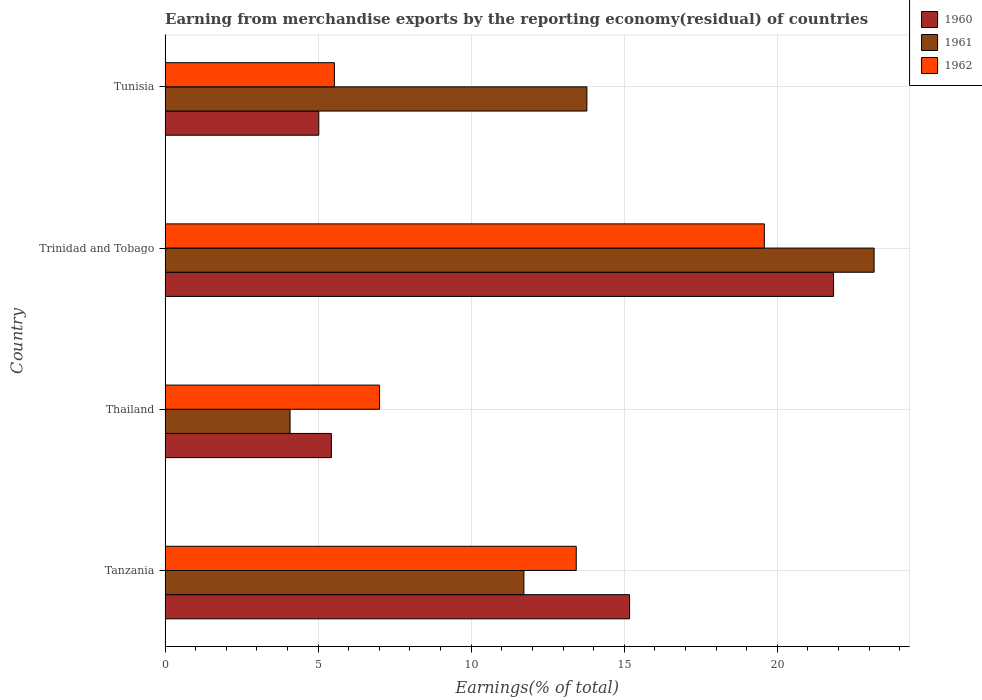How many groups of bars are there?
Your response must be concise. 4. Are the number of bars on each tick of the Y-axis equal?
Offer a terse response. Yes. How many bars are there on the 1st tick from the bottom?
Offer a very short reply. 3. What is the label of the 1st group of bars from the top?
Ensure brevity in your answer.  Tunisia. What is the percentage of amount earned from merchandise exports in 1960 in Tunisia?
Provide a succinct answer. 5.02. Across all countries, what is the maximum percentage of amount earned from merchandise exports in 1962?
Ensure brevity in your answer.  19.58. Across all countries, what is the minimum percentage of amount earned from merchandise exports in 1961?
Your answer should be compact. 4.08. In which country was the percentage of amount earned from merchandise exports in 1961 maximum?
Ensure brevity in your answer.  Trinidad and Tobago. In which country was the percentage of amount earned from merchandise exports in 1962 minimum?
Keep it short and to the point. Tunisia. What is the total percentage of amount earned from merchandise exports in 1962 in the graph?
Offer a terse response. 45.55. What is the difference between the percentage of amount earned from merchandise exports in 1961 in Thailand and that in Trinidad and Tobago?
Your response must be concise. -19.08. What is the difference between the percentage of amount earned from merchandise exports in 1962 in Tunisia and the percentage of amount earned from merchandise exports in 1960 in Trinidad and Tobago?
Your answer should be compact. -16.31. What is the average percentage of amount earned from merchandise exports in 1961 per country?
Make the answer very short. 13.19. What is the difference between the percentage of amount earned from merchandise exports in 1962 and percentage of amount earned from merchandise exports in 1960 in Thailand?
Ensure brevity in your answer.  1.57. What is the ratio of the percentage of amount earned from merchandise exports in 1962 in Tanzania to that in Trinidad and Tobago?
Provide a short and direct response. 0.69. What is the difference between the highest and the second highest percentage of amount earned from merchandise exports in 1960?
Your response must be concise. 6.66. What is the difference between the highest and the lowest percentage of amount earned from merchandise exports in 1960?
Ensure brevity in your answer.  16.82. Is the sum of the percentage of amount earned from merchandise exports in 1960 in Tanzania and Trinidad and Tobago greater than the maximum percentage of amount earned from merchandise exports in 1962 across all countries?
Make the answer very short. Yes. What does the 1st bar from the top in Tunisia represents?
Offer a very short reply. 1962. Is it the case that in every country, the sum of the percentage of amount earned from merchandise exports in 1960 and percentage of amount earned from merchandise exports in 1961 is greater than the percentage of amount earned from merchandise exports in 1962?
Offer a very short reply. Yes. How many countries are there in the graph?
Give a very brief answer. 4. What is the difference between two consecutive major ticks on the X-axis?
Your answer should be compact. 5. Are the values on the major ticks of X-axis written in scientific E-notation?
Ensure brevity in your answer.  No. Does the graph contain grids?
Your response must be concise. Yes. How many legend labels are there?
Offer a very short reply. 3. How are the legend labels stacked?
Your response must be concise. Vertical. What is the title of the graph?
Your answer should be very brief. Earning from merchandise exports by the reporting economy(residual) of countries. Does "2009" appear as one of the legend labels in the graph?
Offer a very short reply. No. What is the label or title of the X-axis?
Give a very brief answer. Earnings(% of total). What is the label or title of the Y-axis?
Your response must be concise. Country. What is the Earnings(% of total) of 1960 in Tanzania?
Make the answer very short. 15.18. What is the Earnings(% of total) of 1961 in Tanzania?
Provide a succinct answer. 11.72. What is the Earnings(% of total) of 1962 in Tanzania?
Keep it short and to the point. 13.43. What is the Earnings(% of total) of 1960 in Thailand?
Give a very brief answer. 5.43. What is the Earnings(% of total) in 1961 in Thailand?
Provide a short and direct response. 4.08. What is the Earnings(% of total) of 1962 in Thailand?
Your answer should be very brief. 7.01. What is the Earnings(% of total) of 1960 in Trinidad and Tobago?
Ensure brevity in your answer.  21.84. What is the Earnings(% of total) of 1961 in Trinidad and Tobago?
Ensure brevity in your answer.  23.16. What is the Earnings(% of total) of 1962 in Trinidad and Tobago?
Your answer should be very brief. 19.58. What is the Earnings(% of total) of 1960 in Tunisia?
Give a very brief answer. 5.02. What is the Earnings(% of total) in 1961 in Tunisia?
Provide a short and direct response. 13.78. What is the Earnings(% of total) in 1962 in Tunisia?
Ensure brevity in your answer.  5.53. Across all countries, what is the maximum Earnings(% of total) of 1960?
Your response must be concise. 21.84. Across all countries, what is the maximum Earnings(% of total) of 1961?
Ensure brevity in your answer.  23.16. Across all countries, what is the maximum Earnings(% of total) of 1962?
Your response must be concise. 19.58. Across all countries, what is the minimum Earnings(% of total) in 1960?
Provide a short and direct response. 5.02. Across all countries, what is the minimum Earnings(% of total) of 1961?
Give a very brief answer. 4.08. Across all countries, what is the minimum Earnings(% of total) of 1962?
Make the answer very short. 5.53. What is the total Earnings(% of total) of 1960 in the graph?
Provide a succinct answer. 47.47. What is the total Earnings(% of total) in 1961 in the graph?
Offer a very short reply. 52.75. What is the total Earnings(% of total) of 1962 in the graph?
Offer a terse response. 45.55. What is the difference between the Earnings(% of total) in 1960 in Tanzania and that in Thailand?
Offer a very short reply. 9.74. What is the difference between the Earnings(% of total) of 1961 in Tanzania and that in Thailand?
Make the answer very short. 7.64. What is the difference between the Earnings(% of total) in 1962 in Tanzania and that in Thailand?
Offer a very short reply. 6.43. What is the difference between the Earnings(% of total) in 1960 in Tanzania and that in Trinidad and Tobago?
Provide a short and direct response. -6.66. What is the difference between the Earnings(% of total) of 1961 in Tanzania and that in Trinidad and Tobago?
Make the answer very short. -11.44. What is the difference between the Earnings(% of total) in 1962 in Tanzania and that in Trinidad and Tobago?
Ensure brevity in your answer.  -6.14. What is the difference between the Earnings(% of total) in 1960 in Tanzania and that in Tunisia?
Ensure brevity in your answer.  10.15. What is the difference between the Earnings(% of total) of 1961 in Tanzania and that in Tunisia?
Keep it short and to the point. -2.06. What is the difference between the Earnings(% of total) in 1962 in Tanzania and that in Tunisia?
Your response must be concise. 7.9. What is the difference between the Earnings(% of total) in 1960 in Thailand and that in Trinidad and Tobago?
Make the answer very short. -16.41. What is the difference between the Earnings(% of total) of 1961 in Thailand and that in Trinidad and Tobago?
Offer a terse response. -19.08. What is the difference between the Earnings(% of total) of 1962 in Thailand and that in Trinidad and Tobago?
Provide a short and direct response. -12.57. What is the difference between the Earnings(% of total) of 1960 in Thailand and that in Tunisia?
Provide a short and direct response. 0.41. What is the difference between the Earnings(% of total) in 1961 in Thailand and that in Tunisia?
Make the answer very short. -9.7. What is the difference between the Earnings(% of total) in 1962 in Thailand and that in Tunisia?
Offer a very short reply. 1.48. What is the difference between the Earnings(% of total) of 1960 in Trinidad and Tobago and that in Tunisia?
Provide a succinct answer. 16.82. What is the difference between the Earnings(% of total) of 1961 in Trinidad and Tobago and that in Tunisia?
Ensure brevity in your answer.  9.38. What is the difference between the Earnings(% of total) of 1962 in Trinidad and Tobago and that in Tunisia?
Offer a very short reply. 14.05. What is the difference between the Earnings(% of total) of 1960 in Tanzania and the Earnings(% of total) of 1961 in Thailand?
Keep it short and to the point. 11.09. What is the difference between the Earnings(% of total) in 1960 in Tanzania and the Earnings(% of total) in 1962 in Thailand?
Offer a terse response. 8.17. What is the difference between the Earnings(% of total) of 1961 in Tanzania and the Earnings(% of total) of 1962 in Thailand?
Your answer should be very brief. 4.72. What is the difference between the Earnings(% of total) of 1960 in Tanzania and the Earnings(% of total) of 1961 in Trinidad and Tobago?
Make the answer very short. -7.99. What is the difference between the Earnings(% of total) in 1960 in Tanzania and the Earnings(% of total) in 1962 in Trinidad and Tobago?
Your answer should be compact. -4.4. What is the difference between the Earnings(% of total) in 1961 in Tanzania and the Earnings(% of total) in 1962 in Trinidad and Tobago?
Keep it short and to the point. -7.86. What is the difference between the Earnings(% of total) in 1960 in Tanzania and the Earnings(% of total) in 1961 in Tunisia?
Keep it short and to the point. 1.39. What is the difference between the Earnings(% of total) of 1960 in Tanzania and the Earnings(% of total) of 1962 in Tunisia?
Your response must be concise. 9.64. What is the difference between the Earnings(% of total) of 1961 in Tanzania and the Earnings(% of total) of 1962 in Tunisia?
Offer a terse response. 6.19. What is the difference between the Earnings(% of total) of 1960 in Thailand and the Earnings(% of total) of 1961 in Trinidad and Tobago?
Keep it short and to the point. -17.73. What is the difference between the Earnings(% of total) of 1960 in Thailand and the Earnings(% of total) of 1962 in Trinidad and Tobago?
Make the answer very short. -14.14. What is the difference between the Earnings(% of total) of 1961 in Thailand and the Earnings(% of total) of 1962 in Trinidad and Tobago?
Your answer should be compact. -15.49. What is the difference between the Earnings(% of total) in 1960 in Thailand and the Earnings(% of total) in 1961 in Tunisia?
Ensure brevity in your answer.  -8.35. What is the difference between the Earnings(% of total) in 1960 in Thailand and the Earnings(% of total) in 1962 in Tunisia?
Your answer should be very brief. -0.1. What is the difference between the Earnings(% of total) in 1961 in Thailand and the Earnings(% of total) in 1962 in Tunisia?
Give a very brief answer. -1.45. What is the difference between the Earnings(% of total) in 1960 in Trinidad and Tobago and the Earnings(% of total) in 1961 in Tunisia?
Provide a short and direct response. 8.06. What is the difference between the Earnings(% of total) of 1960 in Trinidad and Tobago and the Earnings(% of total) of 1962 in Tunisia?
Your response must be concise. 16.31. What is the difference between the Earnings(% of total) in 1961 in Trinidad and Tobago and the Earnings(% of total) in 1962 in Tunisia?
Your answer should be very brief. 17.63. What is the average Earnings(% of total) in 1960 per country?
Keep it short and to the point. 11.87. What is the average Earnings(% of total) in 1961 per country?
Your response must be concise. 13.19. What is the average Earnings(% of total) in 1962 per country?
Provide a short and direct response. 11.39. What is the difference between the Earnings(% of total) of 1960 and Earnings(% of total) of 1961 in Tanzania?
Provide a short and direct response. 3.45. What is the difference between the Earnings(% of total) in 1960 and Earnings(% of total) in 1962 in Tanzania?
Keep it short and to the point. 1.74. What is the difference between the Earnings(% of total) of 1961 and Earnings(% of total) of 1962 in Tanzania?
Keep it short and to the point. -1.71. What is the difference between the Earnings(% of total) in 1960 and Earnings(% of total) in 1961 in Thailand?
Keep it short and to the point. 1.35. What is the difference between the Earnings(% of total) of 1960 and Earnings(% of total) of 1962 in Thailand?
Make the answer very short. -1.57. What is the difference between the Earnings(% of total) of 1961 and Earnings(% of total) of 1962 in Thailand?
Offer a terse response. -2.92. What is the difference between the Earnings(% of total) in 1960 and Earnings(% of total) in 1961 in Trinidad and Tobago?
Make the answer very short. -1.32. What is the difference between the Earnings(% of total) of 1960 and Earnings(% of total) of 1962 in Trinidad and Tobago?
Give a very brief answer. 2.26. What is the difference between the Earnings(% of total) of 1961 and Earnings(% of total) of 1962 in Trinidad and Tobago?
Your response must be concise. 3.59. What is the difference between the Earnings(% of total) of 1960 and Earnings(% of total) of 1961 in Tunisia?
Your response must be concise. -8.76. What is the difference between the Earnings(% of total) of 1960 and Earnings(% of total) of 1962 in Tunisia?
Give a very brief answer. -0.51. What is the difference between the Earnings(% of total) in 1961 and Earnings(% of total) in 1962 in Tunisia?
Provide a short and direct response. 8.25. What is the ratio of the Earnings(% of total) of 1960 in Tanzania to that in Thailand?
Keep it short and to the point. 2.79. What is the ratio of the Earnings(% of total) in 1961 in Tanzania to that in Thailand?
Your answer should be very brief. 2.87. What is the ratio of the Earnings(% of total) of 1962 in Tanzania to that in Thailand?
Offer a very short reply. 1.92. What is the ratio of the Earnings(% of total) in 1960 in Tanzania to that in Trinidad and Tobago?
Make the answer very short. 0.69. What is the ratio of the Earnings(% of total) of 1961 in Tanzania to that in Trinidad and Tobago?
Your response must be concise. 0.51. What is the ratio of the Earnings(% of total) in 1962 in Tanzania to that in Trinidad and Tobago?
Offer a terse response. 0.69. What is the ratio of the Earnings(% of total) in 1960 in Tanzania to that in Tunisia?
Your answer should be very brief. 3.02. What is the ratio of the Earnings(% of total) in 1961 in Tanzania to that in Tunisia?
Make the answer very short. 0.85. What is the ratio of the Earnings(% of total) of 1962 in Tanzania to that in Tunisia?
Offer a very short reply. 2.43. What is the ratio of the Earnings(% of total) in 1960 in Thailand to that in Trinidad and Tobago?
Keep it short and to the point. 0.25. What is the ratio of the Earnings(% of total) in 1961 in Thailand to that in Trinidad and Tobago?
Keep it short and to the point. 0.18. What is the ratio of the Earnings(% of total) in 1962 in Thailand to that in Trinidad and Tobago?
Provide a succinct answer. 0.36. What is the ratio of the Earnings(% of total) of 1960 in Thailand to that in Tunisia?
Make the answer very short. 1.08. What is the ratio of the Earnings(% of total) in 1961 in Thailand to that in Tunisia?
Offer a very short reply. 0.3. What is the ratio of the Earnings(% of total) of 1962 in Thailand to that in Tunisia?
Offer a very short reply. 1.27. What is the ratio of the Earnings(% of total) of 1960 in Trinidad and Tobago to that in Tunisia?
Offer a terse response. 4.35. What is the ratio of the Earnings(% of total) of 1961 in Trinidad and Tobago to that in Tunisia?
Make the answer very short. 1.68. What is the ratio of the Earnings(% of total) of 1962 in Trinidad and Tobago to that in Tunisia?
Give a very brief answer. 3.54. What is the difference between the highest and the second highest Earnings(% of total) of 1960?
Your answer should be very brief. 6.66. What is the difference between the highest and the second highest Earnings(% of total) of 1961?
Offer a very short reply. 9.38. What is the difference between the highest and the second highest Earnings(% of total) of 1962?
Give a very brief answer. 6.14. What is the difference between the highest and the lowest Earnings(% of total) of 1960?
Your answer should be very brief. 16.82. What is the difference between the highest and the lowest Earnings(% of total) of 1961?
Your answer should be compact. 19.08. What is the difference between the highest and the lowest Earnings(% of total) in 1962?
Offer a terse response. 14.05. 